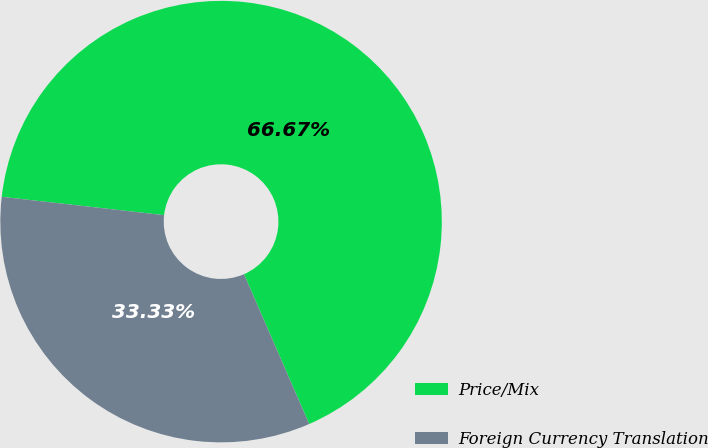Convert chart to OTSL. <chart><loc_0><loc_0><loc_500><loc_500><pie_chart><fcel>Price/Mix<fcel>Foreign Currency Translation<nl><fcel>66.67%<fcel>33.33%<nl></chart> 